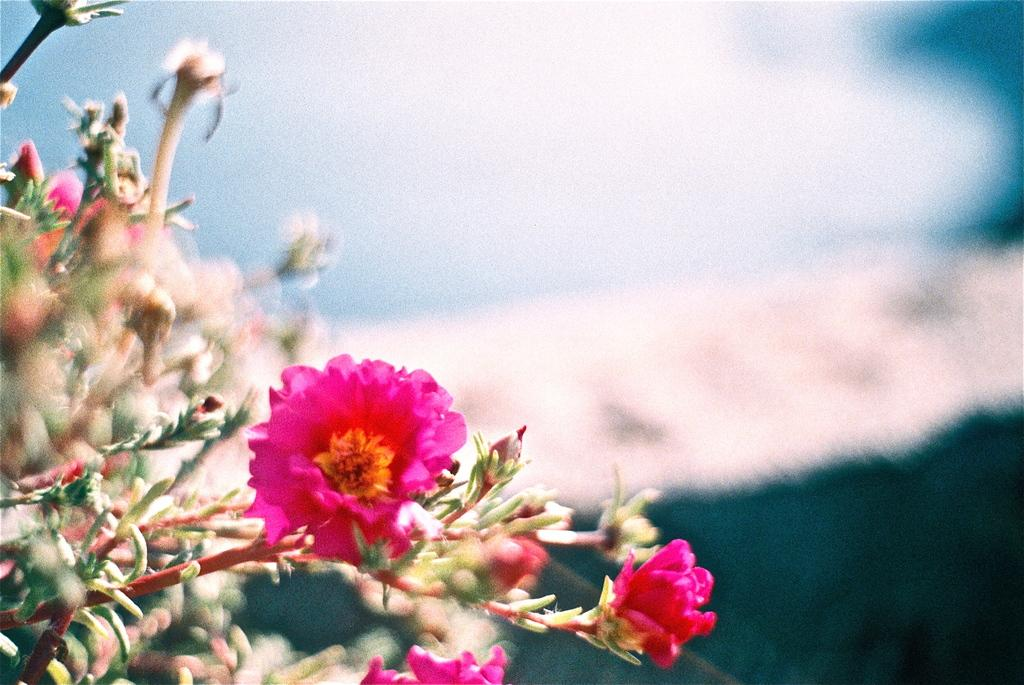What is present in the image? There are flowers in the image. Can you describe the background of the image? The background of the image is blurry. What type of linen is used to cover the flowers in the image? There is no linen present in the image; the flowers are not covered. How much payment is required to purchase the flowers in the image? There is no indication of payment or purchasing in the image; it only shows flowers and a blurry background. 